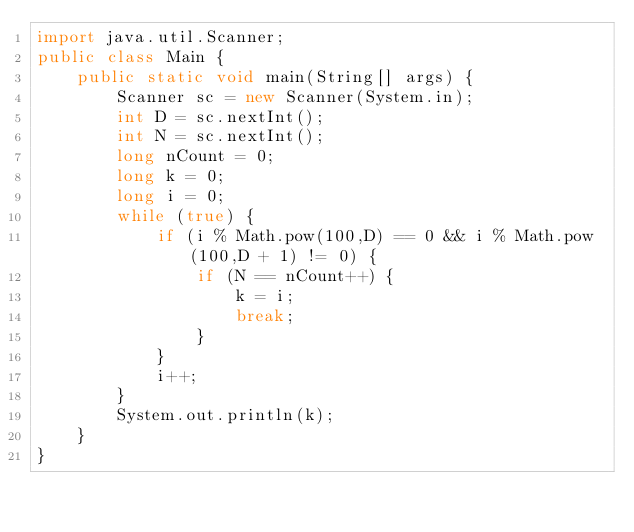Convert code to text. <code><loc_0><loc_0><loc_500><loc_500><_Java_>import java.util.Scanner;
public class Main {
    public static void main(String[] args) {
        Scanner sc = new Scanner(System.in);
        int D = sc.nextInt();
        int N = sc.nextInt();
        long nCount = 0;
        long k = 0;
        long i = 0;
        while (true) {
            if (i % Math.pow(100,D) == 0 && i % Math.pow(100,D + 1) != 0) {
                if (N == nCount++) {
                    k = i;
                    break;
                }
            }
            i++;
        }
        System.out.println(k);
    }
}
</code> 